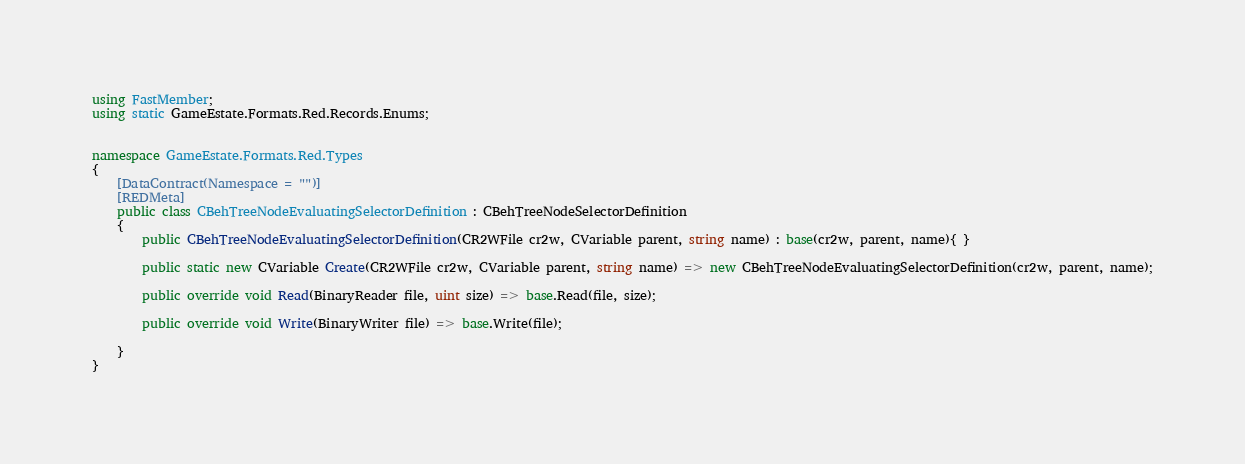Convert code to text. <code><loc_0><loc_0><loc_500><loc_500><_C#_>using FastMember;
using static GameEstate.Formats.Red.Records.Enums;


namespace GameEstate.Formats.Red.Types
{
	[DataContract(Namespace = "")]
	[REDMeta]
	public class CBehTreeNodeEvaluatingSelectorDefinition : CBehTreeNodeSelectorDefinition
	{
		public CBehTreeNodeEvaluatingSelectorDefinition(CR2WFile cr2w, CVariable parent, string name) : base(cr2w, parent, name){ }

		public static new CVariable Create(CR2WFile cr2w, CVariable parent, string name) => new CBehTreeNodeEvaluatingSelectorDefinition(cr2w, parent, name);

		public override void Read(BinaryReader file, uint size) => base.Read(file, size);

		public override void Write(BinaryWriter file) => base.Write(file);

	}
}</code> 